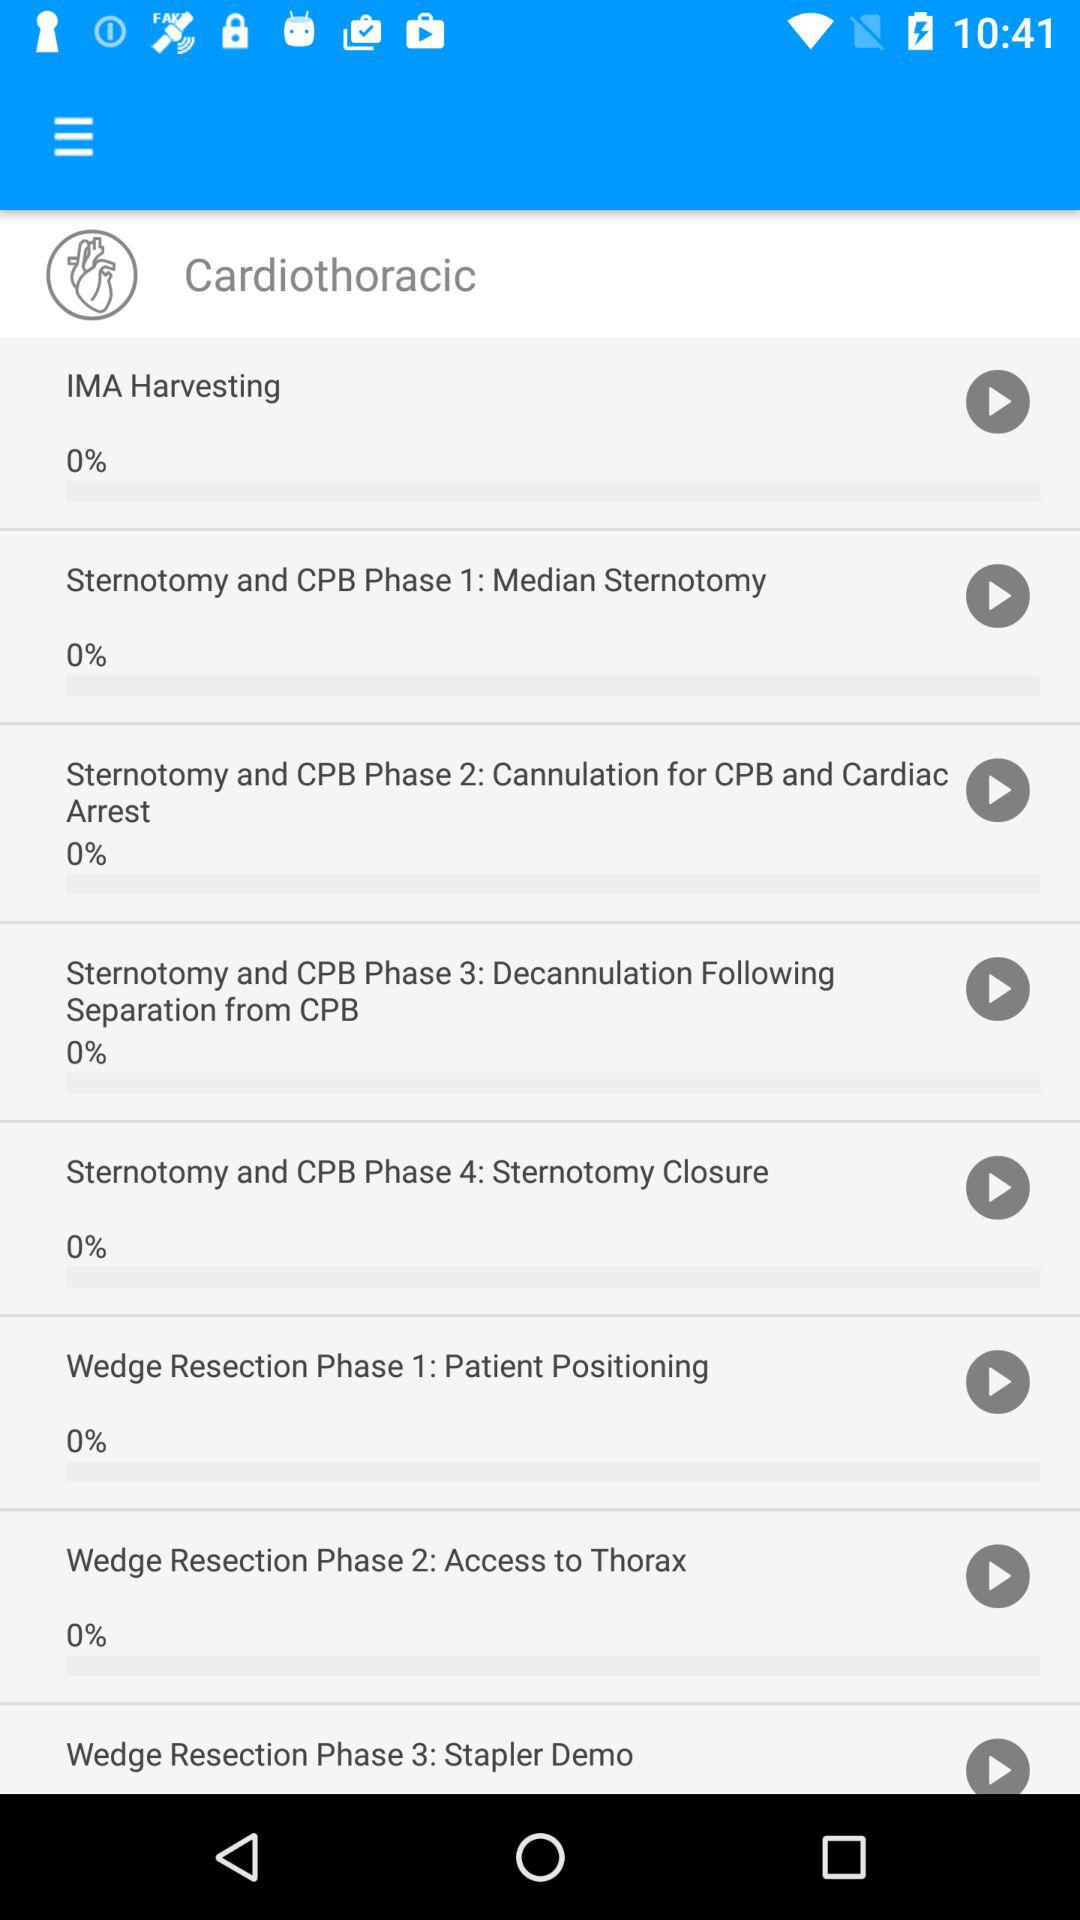How many phases are in the Wedge Resection procedure?
Answer the question using a single word or phrase. 3 